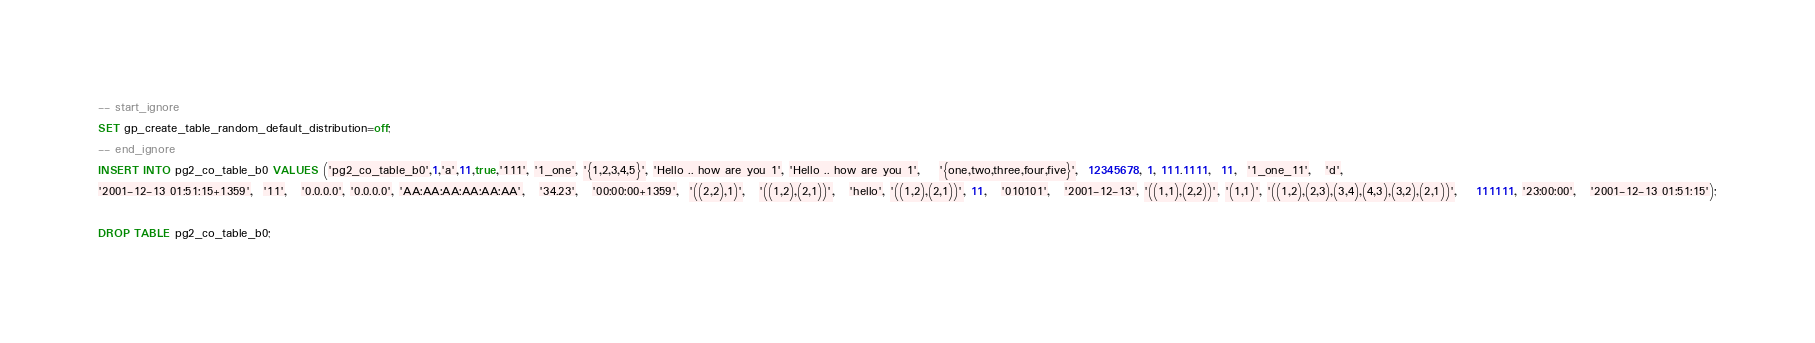<code> <loc_0><loc_0><loc_500><loc_500><_SQL_>-- start_ignore
SET gp_create_table_random_default_distribution=off;
-- end_ignore
INSERT INTO pg2_co_table_b0 VALUES ('pg2_co_table_b0',1,'a',11,true,'111', '1_one', '{1,2,3,4,5}', 'Hello .. how are you 1', 'Hello .. how are you 1',    '{one,two,three,four,five}',  12345678, 1, 111.1111,  11,  '1_one_11',   'd',
'2001-12-13 01:51:15+1359',  '11',   '0.0.0.0', '0.0.0.0', 'AA:AA:AA:AA:AA:AA',   '34.23',   '00:00:00+1359',  '((2,2),1)',   '((1,2),(2,1))',   'hello', '((1,2),(2,1))', 11,   '010101',   '2001-12-13', '((1,1),(2,2))', '(1,1)', '((1,2),(2,3),(3,4),(4,3),(3,2),(2,1))',    111111, '23:00:00',   '2001-12-13 01:51:15');

DROP TABLE pg2_co_table_b0;

</code> 